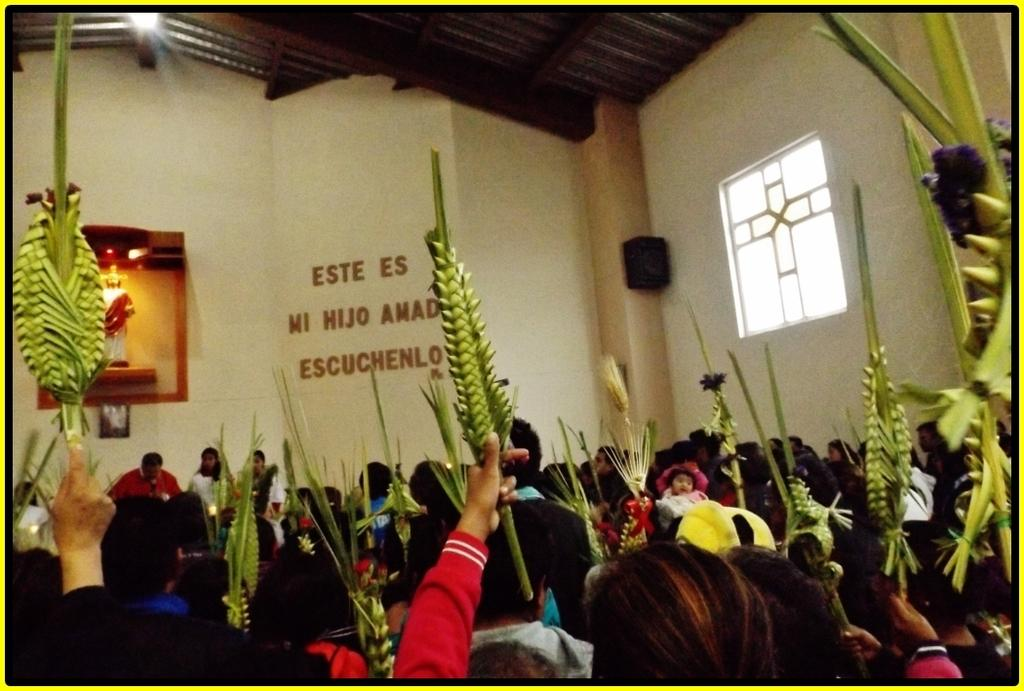How many people are present in the image? There are many people in the image. Where are the people located in the image? The people are in a church. What are the people holding in their hands? The people are holding something in their hands. What type of brush can be seen in the image? There is no brush present in the image. Can you describe the dog that is sitting next to the people in the image? There is no dog present in the image. 